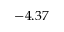Convert formula to latex. <formula><loc_0><loc_0><loc_500><loc_500>- 4 . 3 7</formula> 